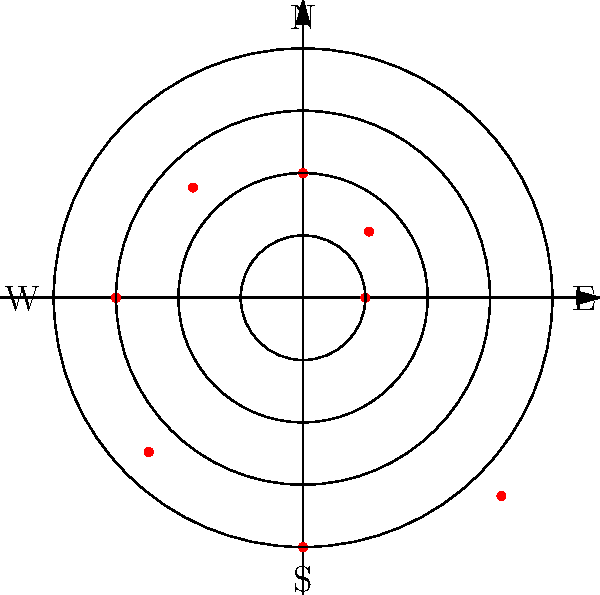Given the polar coordinate plot representing refugee migration patterns from a conflict zone, where each point represents 10,000 refugees, what is the total number of refugees that have fled in the northeastern direction (between 0° and 90°)? To solve this problem, we need to follow these steps:

1. Identify the points in the northeastern quadrant (between 0° and 90°):
   - There are two points in this quadrant.

2. Determine the r-values (distance from the origin) for these points:
   - First point: r ≈ 150 (between the first and second circle)
   - Second point: r ≈ 250 (between the second and third circle)

3. Calculate the number of refugees represented by each point:
   - Each point represents 10,000 refugees

4. Sum up the refugees represented by the two points:
   - First point: 15 * 10,000 = 150,000 refugees
   - Second point: 25 * 10,000 = 250,000 refugees

5. Calculate the total:
   $150,000 + 250,000 = 400,000$ refugees

Therefore, the total number of refugees that have fled in the northeastern direction is 400,000.
Answer: 400,000 refugees 